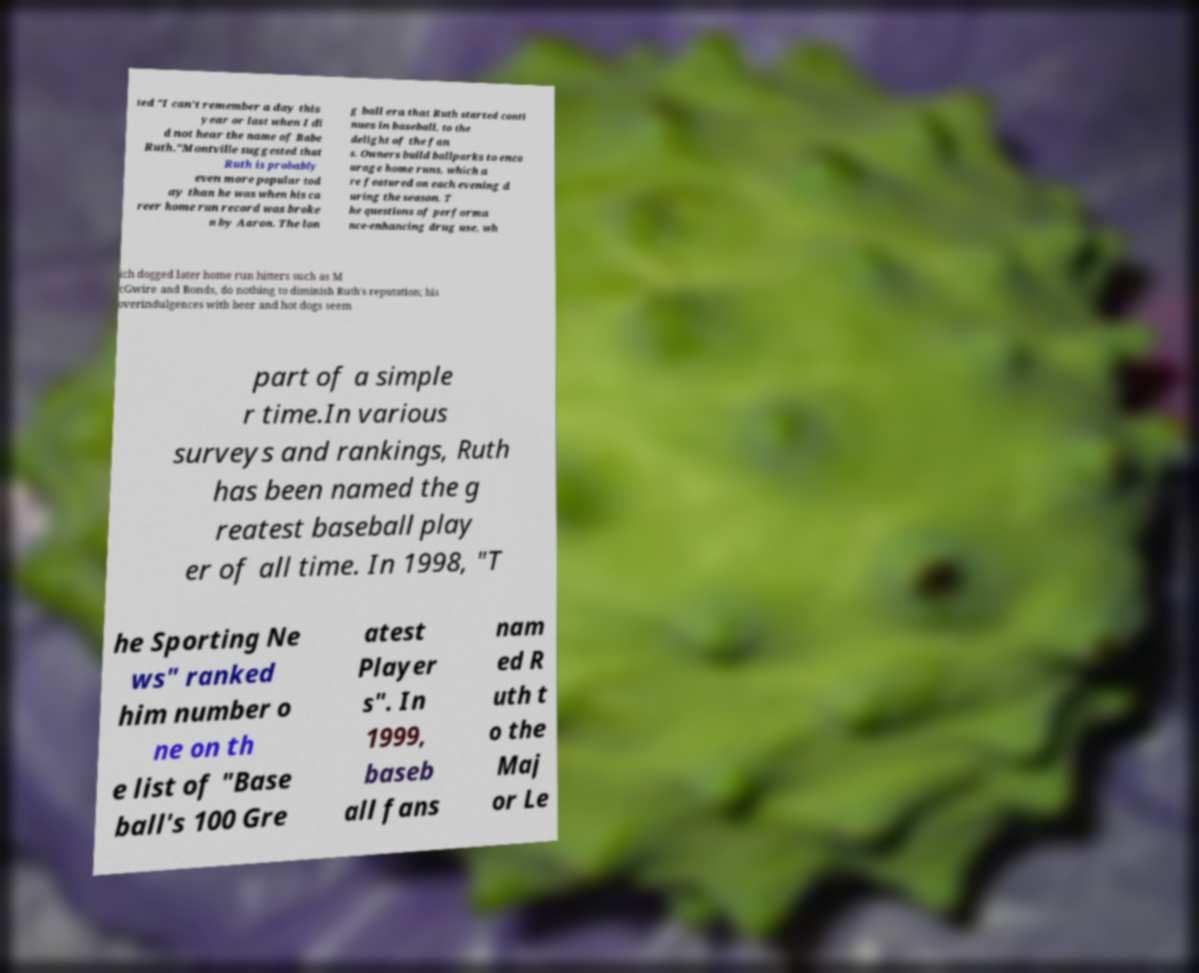There's text embedded in this image that I need extracted. Can you transcribe it verbatim? ted "I can't remember a day this year or last when I di d not hear the name of Babe Ruth."Montville suggested that Ruth is probably even more popular tod ay than he was when his ca reer home run record was broke n by Aaron. The lon g ball era that Ruth started conti nues in baseball, to the delight of the fan s. Owners build ballparks to enco urage home runs, which a re featured on each evening d uring the season. T he questions of performa nce-enhancing drug use, wh ich dogged later home run hitters such as M cGwire and Bonds, do nothing to diminish Ruth's reputation; his overindulgences with beer and hot dogs seem part of a simple r time.In various surveys and rankings, Ruth has been named the g reatest baseball play er of all time. In 1998, "T he Sporting Ne ws" ranked him number o ne on th e list of "Base ball's 100 Gre atest Player s". In 1999, baseb all fans nam ed R uth t o the Maj or Le 